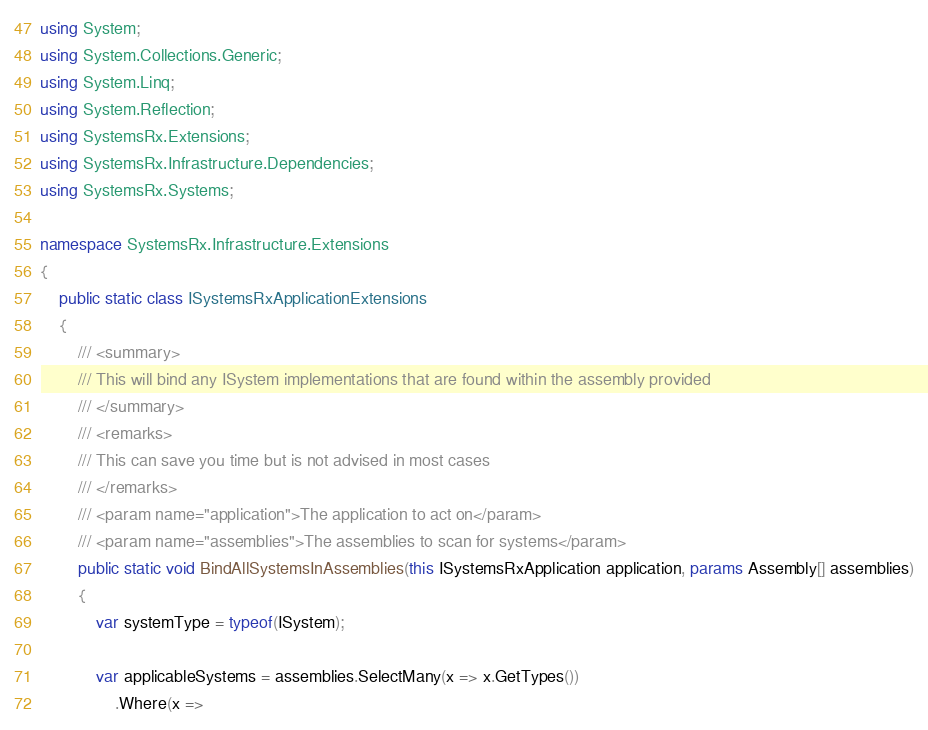Convert code to text. <code><loc_0><loc_0><loc_500><loc_500><_C#_>using System;
using System.Collections.Generic;
using System.Linq;
using System.Reflection;
using SystemsRx.Extensions;
using SystemsRx.Infrastructure.Dependencies;
using SystemsRx.Systems;

namespace SystemsRx.Infrastructure.Extensions
{
    public static class ISystemsRxApplicationExtensions
    {
        /// <summary>
        /// This will bind any ISystem implementations that are found within the assembly provided
        /// </summary>
        /// <remarks>
        /// This can save you time but is not advised in most cases
        /// </remarks>
        /// <param name="application">The application to act on</param>
        /// <param name="assemblies">The assemblies to scan for systems</param>
        public static void BindAllSystemsInAssemblies(this ISystemsRxApplication application, params Assembly[] assemblies)
        {           
            var systemType = typeof(ISystem);           
            
            var applicableSystems = assemblies.SelectMany(x => x.GetTypes())
                .Where(x =></code> 